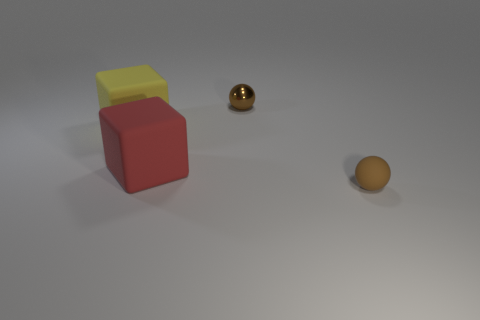There is a small rubber thing that is the same shape as the tiny brown metallic object; what color is it? brown 